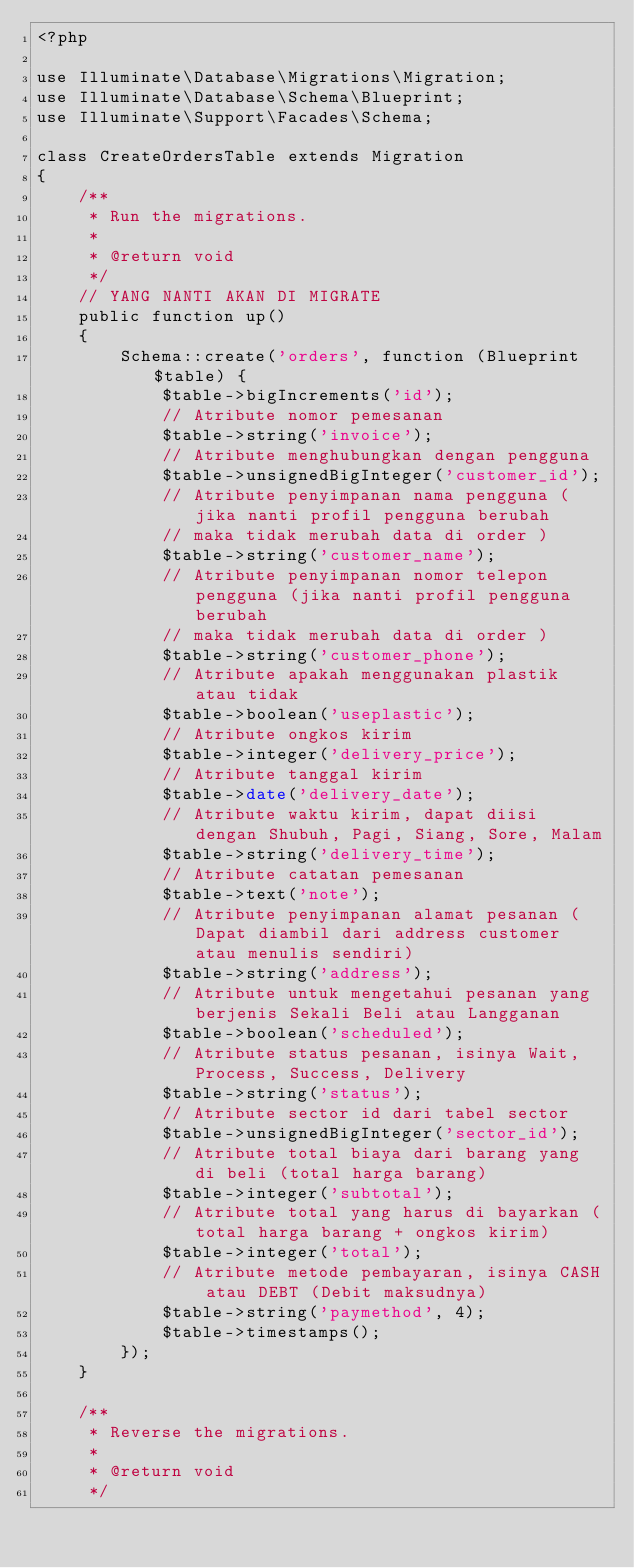<code> <loc_0><loc_0><loc_500><loc_500><_PHP_><?php

use Illuminate\Database\Migrations\Migration;
use Illuminate\Database\Schema\Blueprint;
use Illuminate\Support\Facades\Schema;

class CreateOrdersTable extends Migration
{
    /**
     * Run the migrations.
     *
     * @return void
     */
    // YANG NANTI AKAN DI MIGRATE
    public function up()
    {
        Schema::create('orders', function (Blueprint $table) {
            $table->bigIncrements('id');
            // Atribute nomor pemesanan
            $table->string('invoice');
            // Atribute menghubungkan dengan pengguna 
            $table->unsignedBigInteger('customer_id');
            // Atribute penyimpanan nama pengguna (jika nanti profil pengguna berubah 
            // maka tidak merubah data di order )
            $table->string('customer_name');
            // Atribute penyimpanan nomor telepon pengguna (jika nanti profil pengguna berubah 
            // maka tidak merubah data di order )
            $table->string('customer_phone');
            // Atribute apakah menggunakan plastik atau tidak 
            $table->boolean('useplastic');
            // Atribute ongkos kirim
            $table->integer('delivery_price');
            // Atribute tanggal kirim
            $table->date('delivery_date');
            // Atribute waktu kirim, dapat diisi dengan Shubuh, Pagi, Siang, Sore, Malam 
            $table->string('delivery_time');
            // Atribute catatan pemesanan
            $table->text('note');
            // Atribute penyimpanan alamat pesanan (Dapat diambil dari address customer atau menulis sendiri)
            $table->string('address');
            // Atribute untuk mengetahui pesanan yang berjenis Sekali Beli atau Langganan 
            $table->boolean('scheduled');
            // Atribute status pesanan, isinya Wait, Process, Success, Delivery
            $table->string('status');
            // Atribute sector id dari tabel sector 
            $table->unsignedBigInteger('sector_id');
            // Atribute total biaya dari barang yang di beli (total harga barang)
            $table->integer('subtotal');
            // Atribute total yang harus di bayarkan (total harga barang + ongkos kirim) 
            $table->integer('total');
            // Atribute metode pembayaran, isinya CASH atau DEBT (Debit maksudnya)
            $table->string('paymethod', 4);
            $table->timestamps();
        });
    }

    /**
     * Reverse the migrations.
     *
     * @return void
     */</code> 